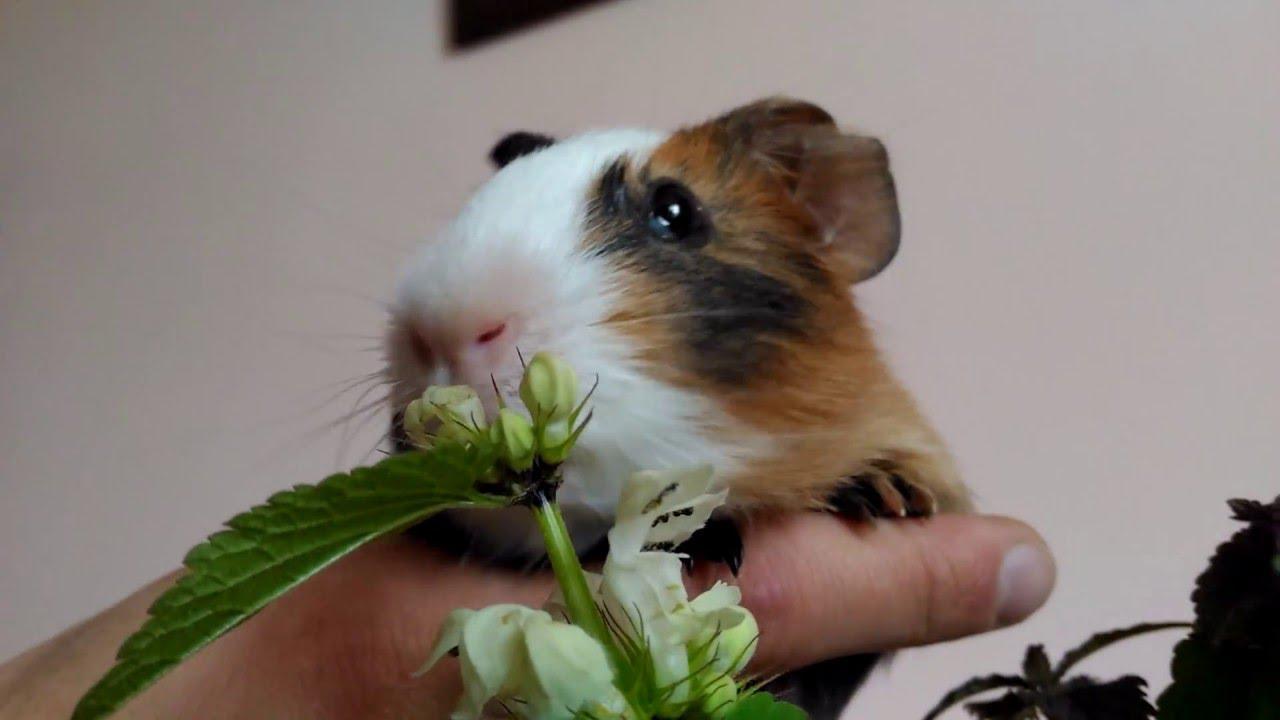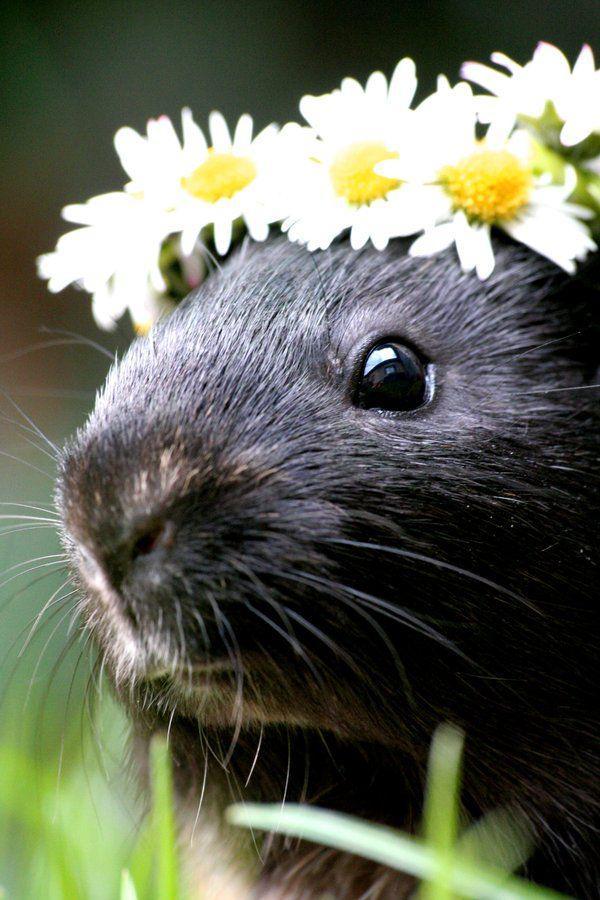The first image is the image on the left, the second image is the image on the right. Given the left and right images, does the statement "One little animal is wearing a bunch of yellow and white daisies on its head." hold true? Answer yes or no. Yes. 